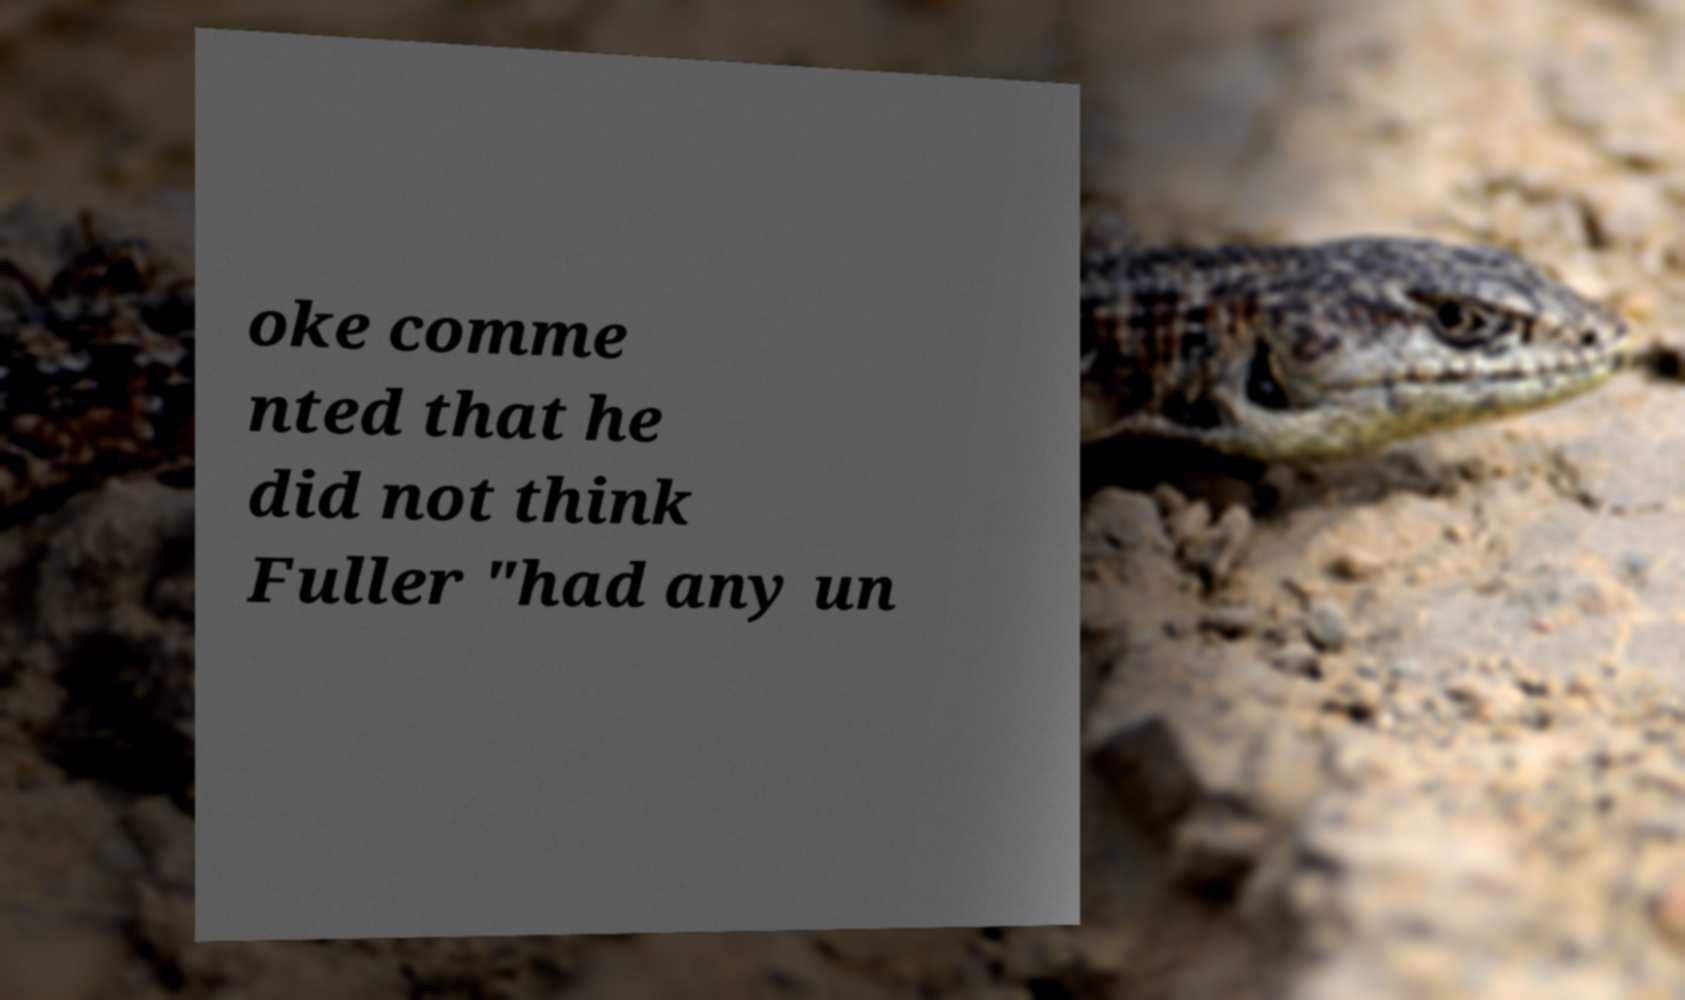For documentation purposes, I need the text within this image transcribed. Could you provide that? oke comme nted that he did not think Fuller "had any un 